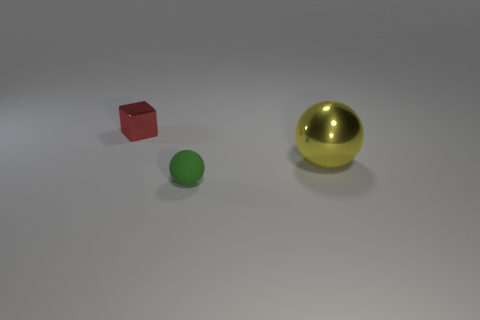Subtract all spheres. How many objects are left? 1 Subtract 1 red blocks. How many objects are left? 2 Subtract 1 blocks. How many blocks are left? 0 Subtract all brown balls. Subtract all purple cylinders. How many balls are left? 2 Subtract all cyan cylinders. How many brown balls are left? 0 Subtract all big red cylinders. Subtract all balls. How many objects are left? 1 Add 3 shiny cubes. How many shiny cubes are left? 4 Add 3 yellow metallic spheres. How many yellow metallic spheres exist? 4 Add 1 small yellow rubber cylinders. How many objects exist? 4 